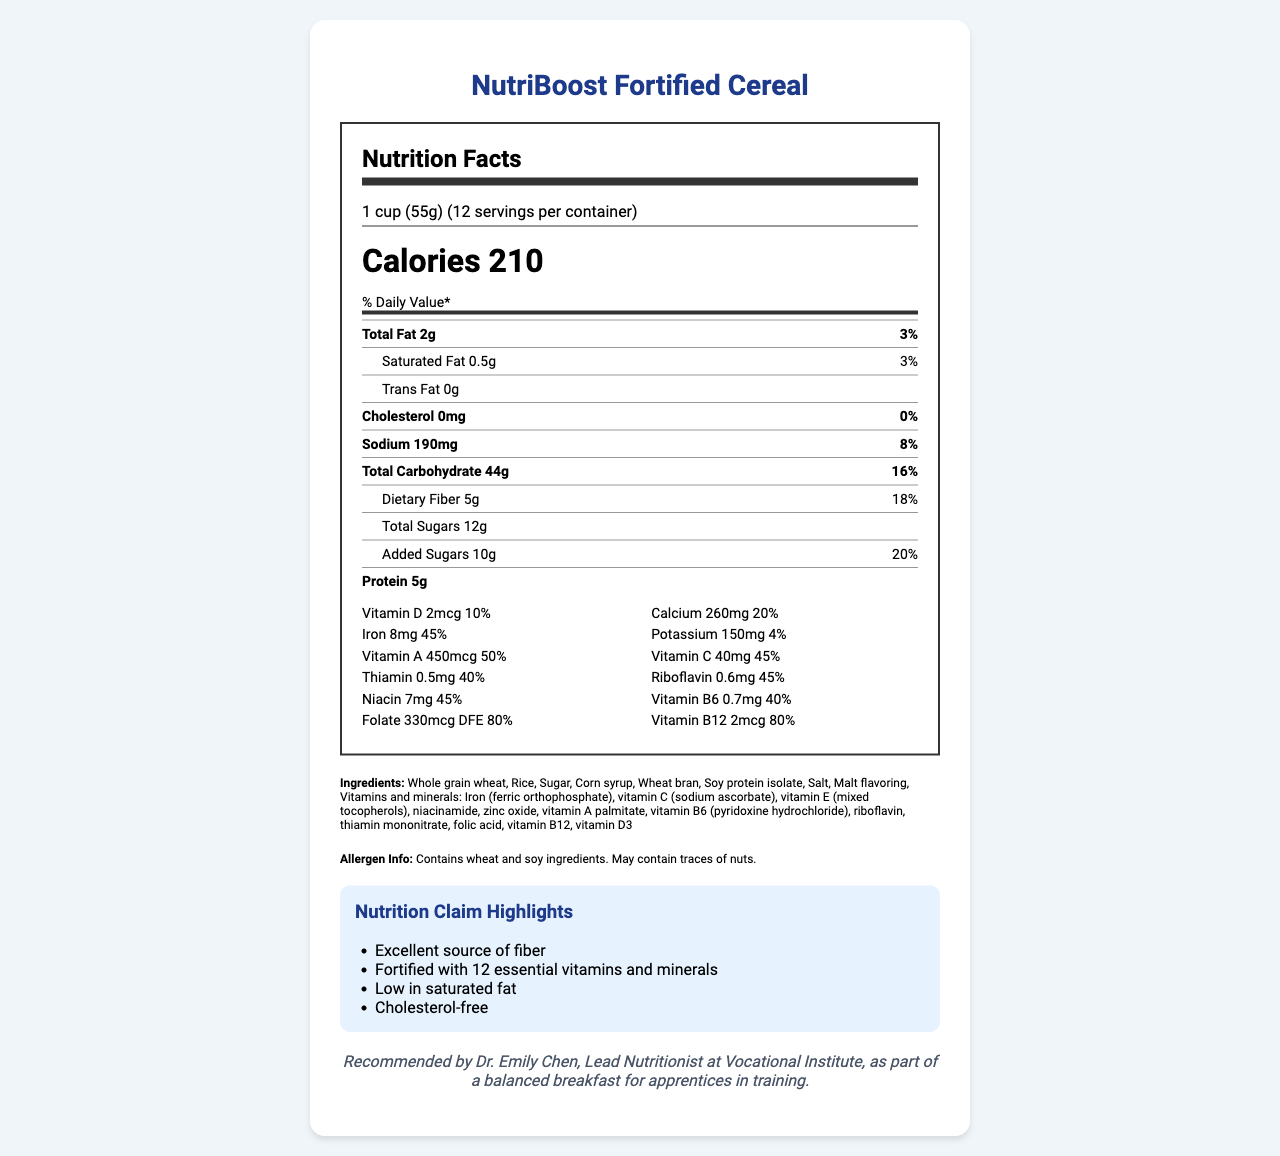what is the total fat per serving? The Total Fat amount per serving is clearly listed as 2g in the document.
Answer: 2g what is the percent Daily Value of dietary fiber in one cup of NutriBoost Fortified Cereal? The percent Daily Value of dietary fiber is directly listed as 18% in the document, under the nutritional information section.
Answer: 18% how much calcium is there in one serving? The amount of calcium in one serving is given as 260mg, and it is annotated under the vitamins and minerals section of the document.
Answer: 260mg what is the serving size? The serving size is stated as "1 cup (55g)" in the section that details serving information.
Answer: 1 cup (55g) how many servings are there per container? The document mentions that there are 12 servings per container, found in the serving information section.
Answer: 12 what are the first three ingredients listed? The ingredients list starts with "Whole grain wheat, Rice, Sugar" which are the first three ingredients listed.
Answer: Whole grain wheat, Rice, Sugar is there any cholesterol in NutriBoost Fortified Cereal? The document states that the cholesterol amount is 0mg, indicating that there is no cholesterol.
Answer: No which vitamin has the highest percent Daily Value? A. Vitamin D B. Calcium C. Vitamin A D. Folate Vitamin A has the highest percent Daily Value at 50%, as shown in the vitamins and minerals section.
Answer: C the cereal is labeled as an excellent source of which nutrient? A. Protein B. Fiber C. Sugars D. Fat The highlights section of the document specifically labels the cereal as an "Excellent source of fiber."
Answer: B is NutriBoost Fortified Cereal gluten-free? The document provides allergen information which mentions wheat and soy, but it does not explicitly state if the cereal is gluten-free or not.
Answer: Cannot be determined can this cereal be considered low in saturated fat? The highlights section claims the cereal is "Low in saturated fat," and the nutritional information supports this with only 0.5g of saturated fat.
Answer: Yes how much protein is there in one serving? The protein content per serving is listed as 5g in the nutritional information section.
Answer: 5g describe the main idea of the document. The document outlines the nutritional facts, ingredients, allergen information, and certifications for NutriBoost Fortified Cereal, emphasizing its benefits such as high fiber content and a variety of essential vitamins and minerals recommended for apprentices in training.
Answer: The document provides detailed nutritional information about NutriBoost Fortified Cereal, which is recommended by the Vocational Institute's nutrition course. It includes information about serving size, calories, macronutrients, vitamins, and minerals. It also highlights key nutritional claims, ingredients, allergens, and certifications. 